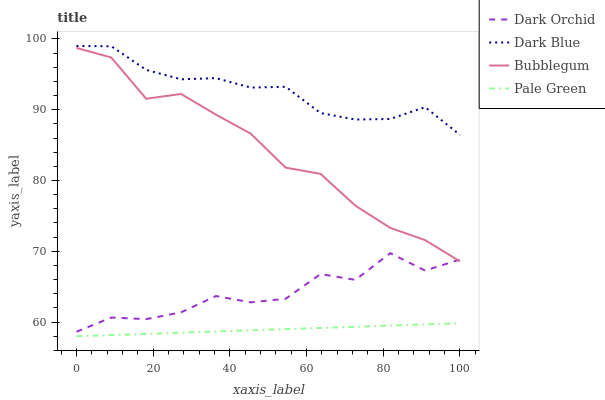Does Pale Green have the minimum area under the curve?
Answer yes or no. Yes. Does Dark Blue have the maximum area under the curve?
Answer yes or no. Yes. Does Bubblegum have the minimum area under the curve?
Answer yes or no. No. Does Bubblegum have the maximum area under the curve?
Answer yes or no. No. Is Pale Green the smoothest?
Answer yes or no. Yes. Is Dark Orchid the roughest?
Answer yes or no. Yes. Is Bubblegum the smoothest?
Answer yes or no. No. Is Bubblegum the roughest?
Answer yes or no. No. Does Pale Green have the lowest value?
Answer yes or no. Yes. Does Bubblegum have the lowest value?
Answer yes or no. No. Does Dark Blue have the highest value?
Answer yes or no. Yes. Does Bubblegum have the highest value?
Answer yes or no. No. Is Pale Green less than Bubblegum?
Answer yes or no. Yes. Is Dark Blue greater than Bubblegum?
Answer yes or no. Yes. Does Bubblegum intersect Dark Orchid?
Answer yes or no. Yes. Is Bubblegum less than Dark Orchid?
Answer yes or no. No. Is Bubblegum greater than Dark Orchid?
Answer yes or no. No. Does Pale Green intersect Bubblegum?
Answer yes or no. No. 